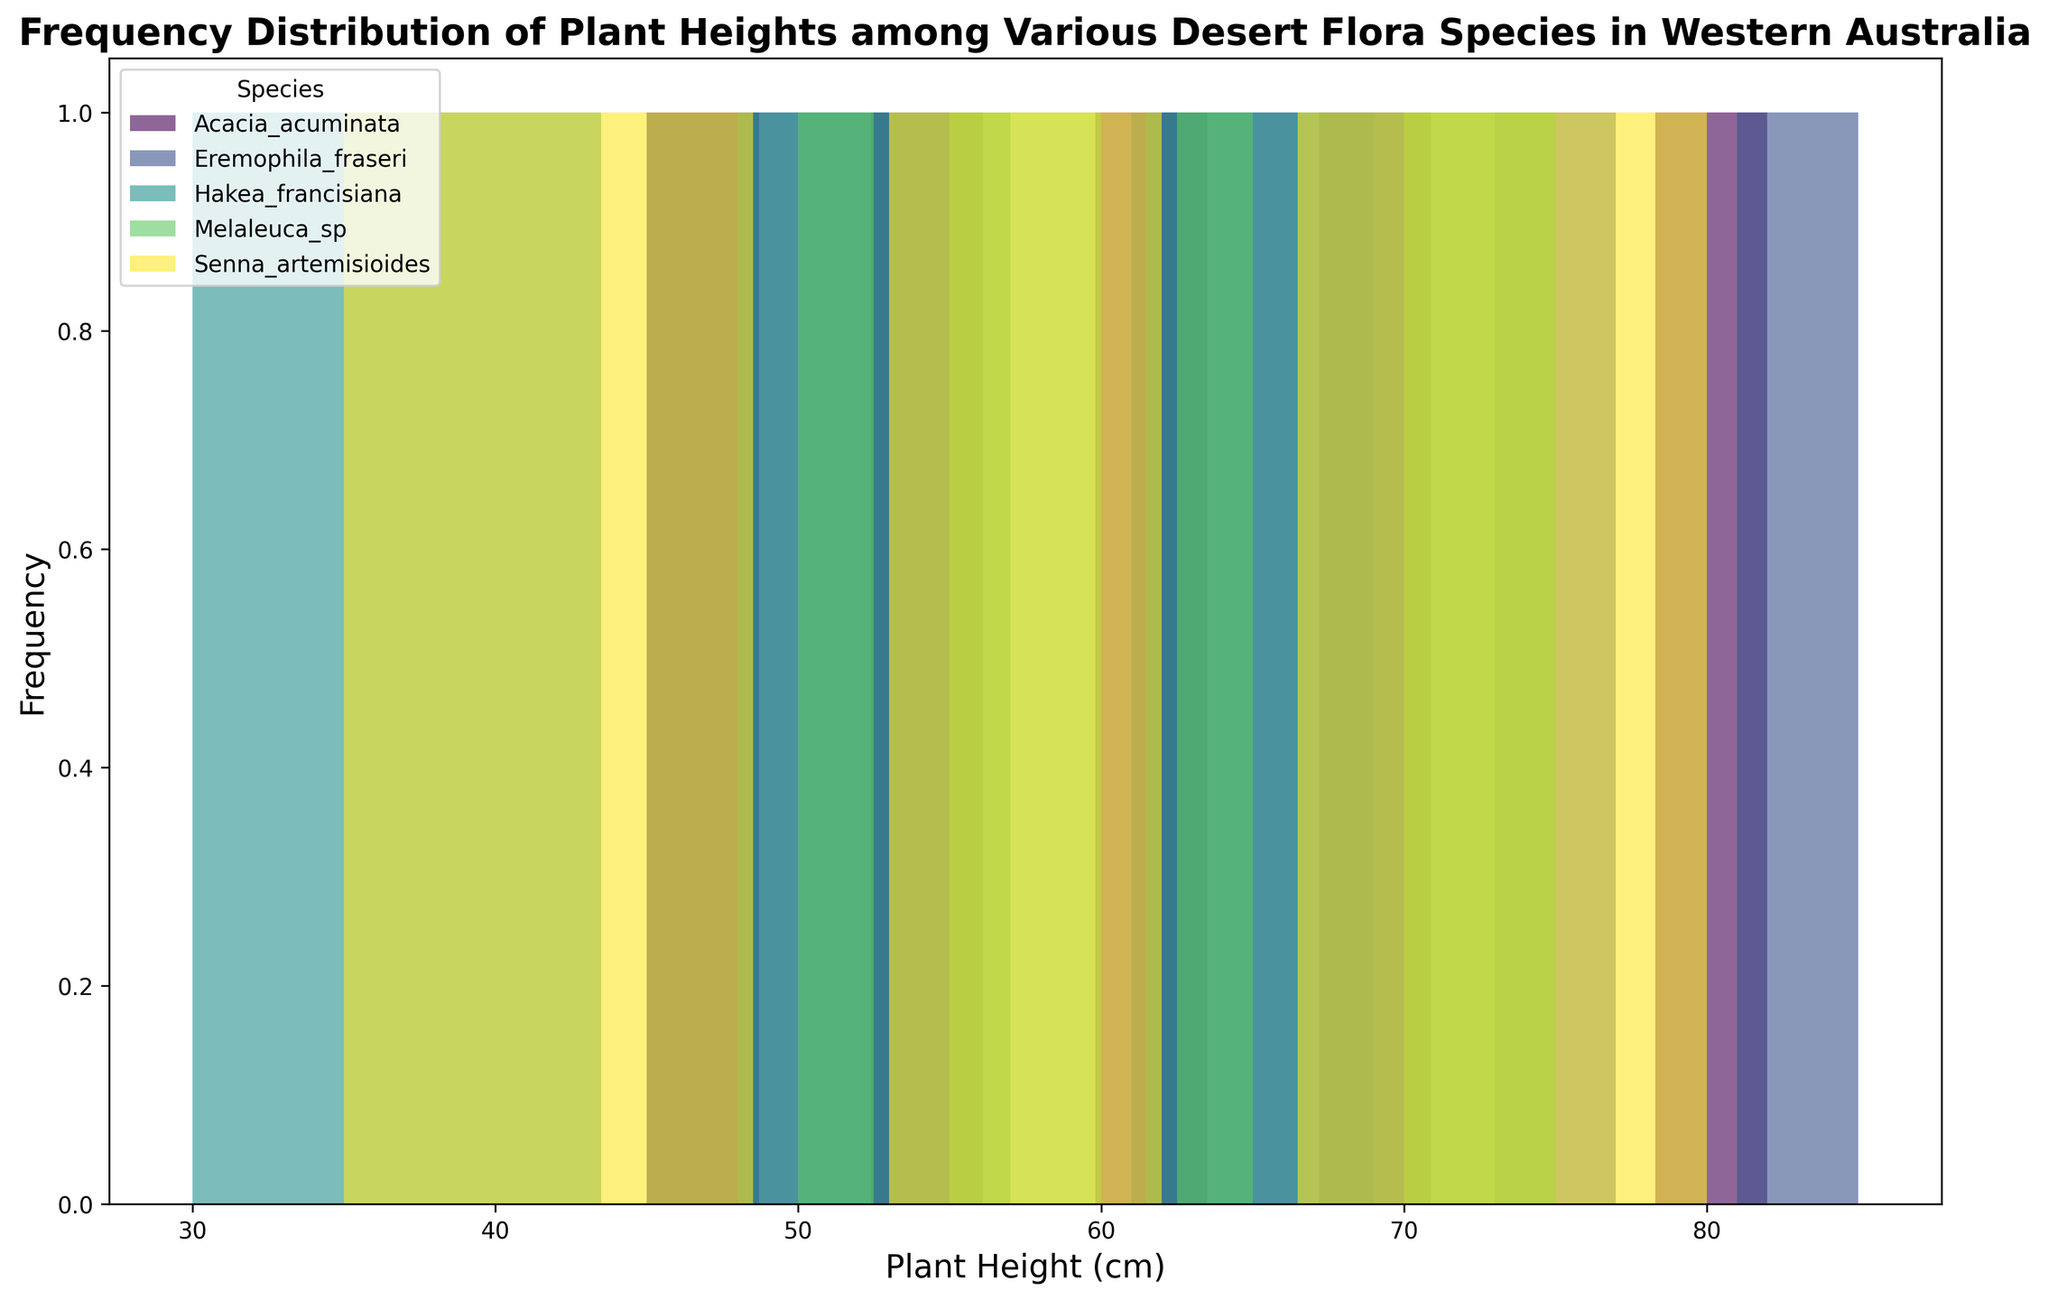What's the tallest plant height recorded among all the species? To identify the tallest plant height, look for the maximum bar in the histogram, regardless of species, and note its value on the x-axis. From the histogram, the tallest height is located at 85 cm.
Answer: 85 cm Which species has the most frequent plant height between 50 cm and 60 cm? To determine the most frequent plant height within 50 cm to 60 cm, examine the histogram bars corresponding to each species in that range. Notice which species has the highest frequency within these bins. In the histogram, Melaleuca_sp shows a peak within 50 cm to 60 cm range.
Answer: Melaleuca_sp What is the range of heights for Hakea francisiana? Look at the histogram for the distribution of heights specific to Hakea francisiana, identifying the smallest and largest values on the x-axis where its bars appear. The minimum is 30 cm, and the maximum is 75 cm. The range is the difference between these two values.
Answer: 45 cm Which species exhibits the most variability in plant heights? Variability can be visually assessed by the spread and distribution of the bars for each species. The species whose distribution covers the widest range on the x-axis while having varied heights within the range is Hakea francisiana. The bars show a wide and varied spread.
Answer: Hakea francisiana Compare the plant heights of Acacia acuminata and Senna artemisioides. Which one generally grows taller? To compare, observe the bars' heights for both species on the x-axis. Acacia acuminata has its tallest bar around 82 cm, whereas Senna artemisioides goes up to 80 cm. Acacia acuminata frequently shows taller plant heights.
Answer: Acacia acuminata What is the average height range (in cm) where most species overlap? Calculate the overlapping ranges visually. Most species seem to have bars between the range of 45 cm to 75 cm. This is the common range where the distributions intersect.
Answer: 45 cm to 75 cm How does the frequency of plant height for Eremophila fraseri at 73 cm compare to its frequency at 52 cm? Compare the heights of the two respective bars of Eremophila fraseri at 73 cm and 52 cm on the histogram. Eremophila_fraseri shows a higher frequency at 73 cm than at 52 cm.
Answer: Higher at 73 cm What is the least common height among all species combined? Identify the height with the lowest frequency across all species by finding the shortest bar in the histogram. Heights in the range of 30 cm (based on Hakea_francisiana) appear to be least common.
Answer: 30 cm 